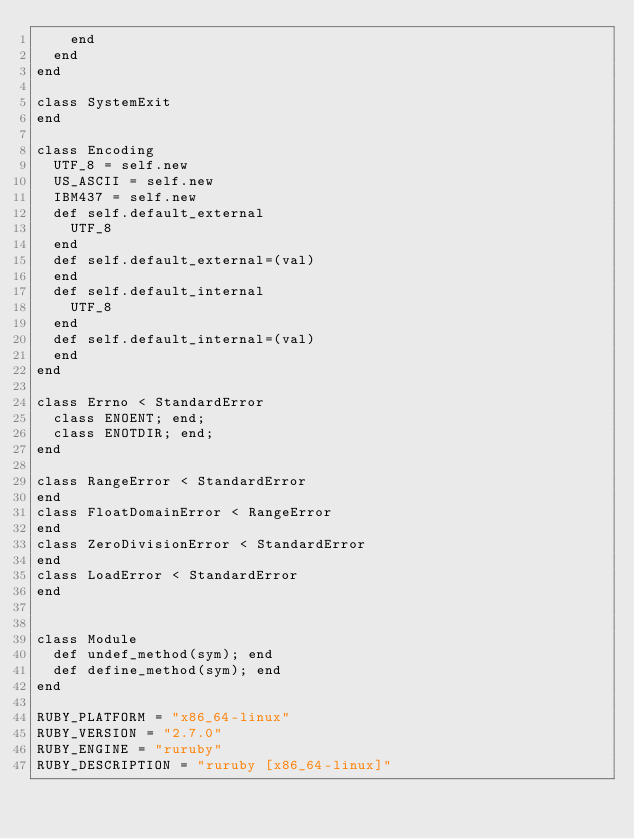Convert code to text. <code><loc_0><loc_0><loc_500><loc_500><_Ruby_>    end
  end
end

class SystemExit
end

class Encoding
  UTF_8 = self.new
  US_ASCII = self.new
  IBM437 = self.new
  def self.default_external
    UTF_8
  end
  def self.default_external=(val)
  end
  def self.default_internal
    UTF_8
  end
  def self.default_internal=(val)
  end
end

class Errno < StandardError
  class ENOENT; end;
  class ENOTDIR; end;
end

class RangeError < StandardError
end
class FloatDomainError < RangeError
end
class ZeroDivisionError < StandardError
end
class LoadError < StandardError
end


class Module
  def undef_method(sym); end
  def define_method(sym); end
end

RUBY_PLATFORM = "x86_64-linux"
RUBY_VERSION = "2.7.0"
RUBY_ENGINE = "ruruby"
RUBY_DESCRIPTION = "ruruby [x86_64-linux]"
</code> 